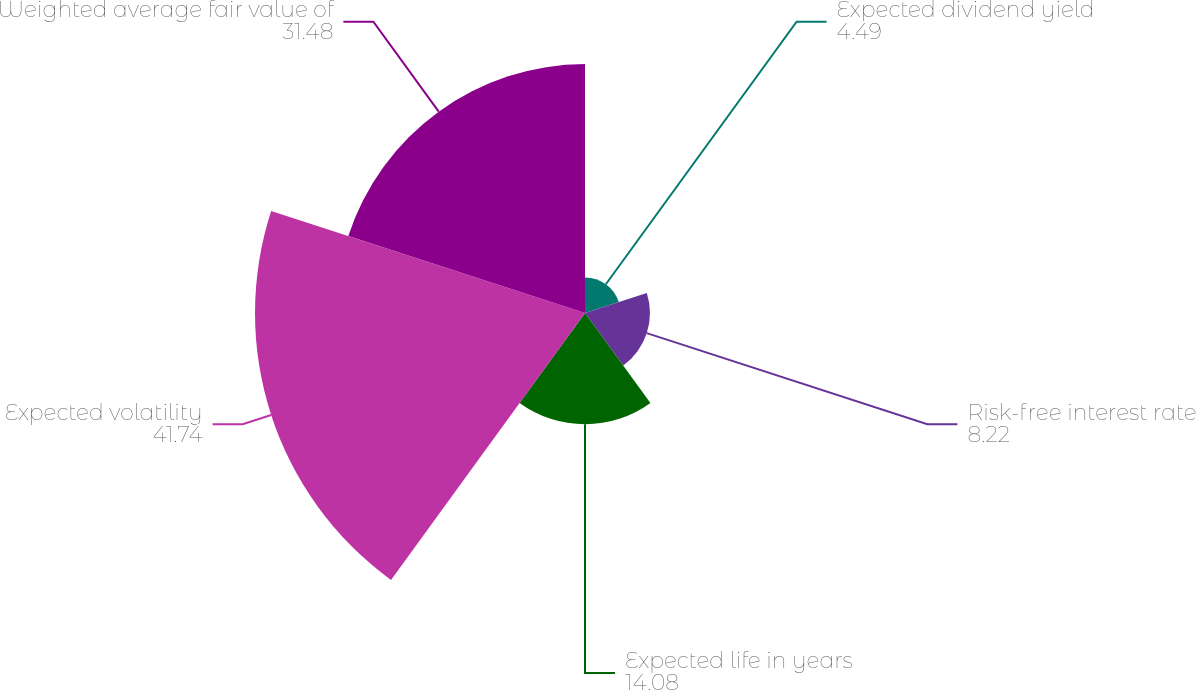Convert chart. <chart><loc_0><loc_0><loc_500><loc_500><pie_chart><fcel>Expected dividend yield<fcel>Risk-free interest rate<fcel>Expected life in years<fcel>Expected volatility<fcel>Weighted average fair value of<nl><fcel>4.49%<fcel>8.22%<fcel>14.08%<fcel>41.74%<fcel>31.48%<nl></chart> 